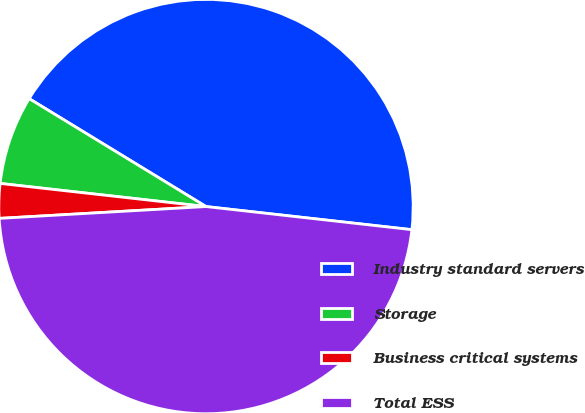Convert chart to OTSL. <chart><loc_0><loc_0><loc_500><loc_500><pie_chart><fcel>Industry standard servers<fcel>Storage<fcel>Business critical systems<fcel>Total ESS<nl><fcel>43.06%<fcel>6.94%<fcel>2.69%<fcel>47.31%<nl></chart> 